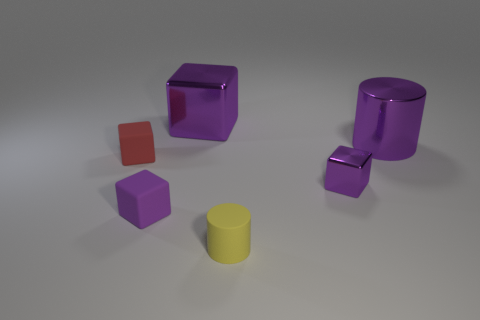Subtract all cyan balls. How many purple cubes are left? 3 Subtract all cyan cubes. Subtract all purple spheres. How many cubes are left? 4 Add 1 large purple cylinders. How many objects exist? 7 Subtract all blocks. How many objects are left? 2 Add 4 small yellow rubber cylinders. How many small yellow rubber cylinders exist? 5 Subtract 0 gray blocks. How many objects are left? 6 Subtract all cylinders. Subtract all tiny cylinders. How many objects are left? 3 Add 6 tiny cylinders. How many tiny cylinders are left? 7 